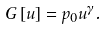<formula> <loc_0><loc_0><loc_500><loc_500>G \left [ u \right ] = p _ { 0 } u ^ { \gamma } .</formula> 